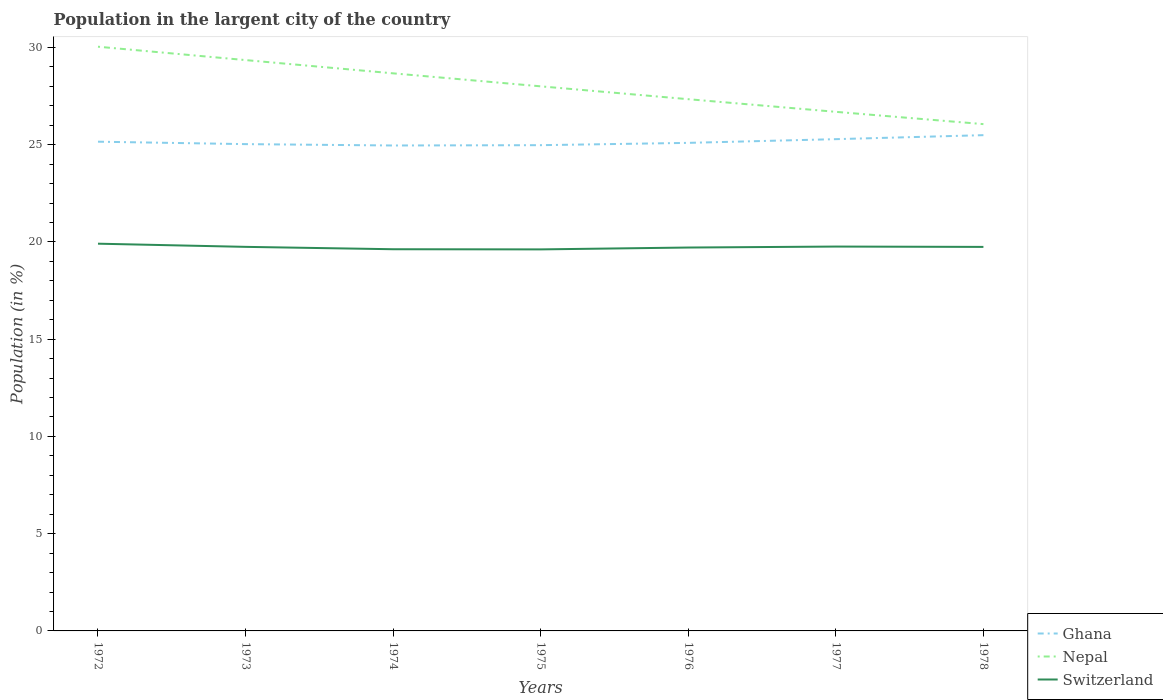Does the line corresponding to Ghana intersect with the line corresponding to Switzerland?
Offer a very short reply. No. Across all years, what is the maximum percentage of population in the largent city in Nepal?
Make the answer very short. 26.06. In which year was the percentage of population in the largent city in Nepal maximum?
Ensure brevity in your answer.  1978. What is the total percentage of population in the largent city in Ghana in the graph?
Ensure brevity in your answer.  -0.34. What is the difference between the highest and the second highest percentage of population in the largent city in Switzerland?
Ensure brevity in your answer.  0.29. What is the difference between the highest and the lowest percentage of population in the largent city in Ghana?
Give a very brief answer. 3. Are the values on the major ticks of Y-axis written in scientific E-notation?
Offer a very short reply. No. Does the graph contain grids?
Your answer should be compact. No. Where does the legend appear in the graph?
Your answer should be compact. Bottom right. How many legend labels are there?
Ensure brevity in your answer.  3. What is the title of the graph?
Offer a very short reply. Population in the largent city of the country. Does "Benin" appear as one of the legend labels in the graph?
Offer a terse response. No. What is the label or title of the X-axis?
Your response must be concise. Years. What is the label or title of the Y-axis?
Provide a succinct answer. Population (in %). What is the Population (in %) of Ghana in 1972?
Provide a succinct answer. 25.15. What is the Population (in %) of Nepal in 1972?
Make the answer very short. 30.04. What is the Population (in %) in Switzerland in 1972?
Ensure brevity in your answer.  19.91. What is the Population (in %) in Ghana in 1973?
Provide a short and direct response. 25.03. What is the Population (in %) of Nepal in 1973?
Provide a short and direct response. 29.35. What is the Population (in %) in Switzerland in 1973?
Offer a very short reply. 19.75. What is the Population (in %) of Ghana in 1974?
Ensure brevity in your answer.  24.96. What is the Population (in %) of Nepal in 1974?
Your answer should be very brief. 28.67. What is the Population (in %) in Switzerland in 1974?
Provide a short and direct response. 19.62. What is the Population (in %) in Ghana in 1975?
Give a very brief answer. 24.97. What is the Population (in %) of Nepal in 1975?
Provide a short and direct response. 28. What is the Population (in %) of Switzerland in 1975?
Offer a terse response. 19.62. What is the Population (in %) in Ghana in 1976?
Your answer should be compact. 25.09. What is the Population (in %) in Nepal in 1976?
Provide a succinct answer. 27.34. What is the Population (in %) in Switzerland in 1976?
Ensure brevity in your answer.  19.71. What is the Population (in %) in Ghana in 1977?
Offer a terse response. 25.28. What is the Population (in %) of Nepal in 1977?
Your answer should be very brief. 26.69. What is the Population (in %) of Switzerland in 1977?
Your response must be concise. 19.76. What is the Population (in %) of Ghana in 1978?
Your answer should be very brief. 25.49. What is the Population (in %) in Nepal in 1978?
Provide a short and direct response. 26.06. What is the Population (in %) in Switzerland in 1978?
Provide a short and direct response. 19.74. Across all years, what is the maximum Population (in %) of Ghana?
Your answer should be very brief. 25.49. Across all years, what is the maximum Population (in %) in Nepal?
Your answer should be very brief. 30.04. Across all years, what is the maximum Population (in %) in Switzerland?
Make the answer very short. 19.91. Across all years, what is the minimum Population (in %) in Ghana?
Provide a succinct answer. 24.96. Across all years, what is the minimum Population (in %) in Nepal?
Your answer should be very brief. 26.06. Across all years, what is the minimum Population (in %) in Switzerland?
Give a very brief answer. 19.62. What is the total Population (in %) of Ghana in the graph?
Your answer should be very brief. 175.98. What is the total Population (in %) in Nepal in the graph?
Your answer should be very brief. 196.13. What is the total Population (in %) of Switzerland in the graph?
Your response must be concise. 138.11. What is the difference between the Population (in %) of Ghana in 1972 and that in 1973?
Your answer should be very brief. 0.12. What is the difference between the Population (in %) of Nepal in 1972 and that in 1973?
Your response must be concise. 0.69. What is the difference between the Population (in %) in Switzerland in 1972 and that in 1973?
Ensure brevity in your answer.  0.16. What is the difference between the Population (in %) in Ghana in 1972 and that in 1974?
Your response must be concise. 0.2. What is the difference between the Population (in %) of Nepal in 1972 and that in 1974?
Your response must be concise. 1.37. What is the difference between the Population (in %) in Switzerland in 1972 and that in 1974?
Offer a terse response. 0.29. What is the difference between the Population (in %) in Ghana in 1972 and that in 1975?
Make the answer very short. 0.18. What is the difference between the Population (in %) of Nepal in 1972 and that in 1975?
Provide a succinct answer. 2.04. What is the difference between the Population (in %) of Switzerland in 1972 and that in 1975?
Give a very brief answer. 0.29. What is the difference between the Population (in %) of Ghana in 1972 and that in 1976?
Your answer should be very brief. 0.06. What is the difference between the Population (in %) in Nepal in 1972 and that in 1976?
Your response must be concise. 2.7. What is the difference between the Population (in %) of Switzerland in 1972 and that in 1976?
Keep it short and to the point. 0.2. What is the difference between the Population (in %) of Ghana in 1972 and that in 1977?
Provide a succinct answer. -0.13. What is the difference between the Population (in %) in Nepal in 1972 and that in 1977?
Ensure brevity in your answer.  3.35. What is the difference between the Population (in %) in Switzerland in 1972 and that in 1977?
Give a very brief answer. 0.15. What is the difference between the Population (in %) of Ghana in 1972 and that in 1978?
Offer a very short reply. -0.34. What is the difference between the Population (in %) in Nepal in 1972 and that in 1978?
Offer a terse response. 3.98. What is the difference between the Population (in %) of Switzerland in 1972 and that in 1978?
Provide a short and direct response. 0.17. What is the difference between the Population (in %) of Ghana in 1973 and that in 1974?
Your answer should be very brief. 0.07. What is the difference between the Population (in %) in Nepal in 1973 and that in 1974?
Offer a very short reply. 0.68. What is the difference between the Population (in %) of Switzerland in 1973 and that in 1974?
Offer a terse response. 0.12. What is the difference between the Population (in %) in Ghana in 1973 and that in 1975?
Provide a short and direct response. 0.05. What is the difference between the Population (in %) of Nepal in 1973 and that in 1975?
Offer a very short reply. 1.35. What is the difference between the Population (in %) in Switzerland in 1973 and that in 1975?
Give a very brief answer. 0.13. What is the difference between the Population (in %) in Ghana in 1973 and that in 1976?
Keep it short and to the point. -0.06. What is the difference between the Population (in %) in Nepal in 1973 and that in 1976?
Keep it short and to the point. 2.01. What is the difference between the Population (in %) of Switzerland in 1973 and that in 1976?
Give a very brief answer. 0.03. What is the difference between the Population (in %) in Ghana in 1973 and that in 1977?
Your answer should be very brief. -0.26. What is the difference between the Population (in %) of Nepal in 1973 and that in 1977?
Provide a succinct answer. 2.66. What is the difference between the Population (in %) of Switzerland in 1973 and that in 1977?
Offer a terse response. -0.02. What is the difference between the Population (in %) of Ghana in 1973 and that in 1978?
Give a very brief answer. -0.46. What is the difference between the Population (in %) of Nepal in 1973 and that in 1978?
Keep it short and to the point. 3.29. What is the difference between the Population (in %) of Switzerland in 1973 and that in 1978?
Your answer should be very brief. 0. What is the difference between the Population (in %) of Ghana in 1974 and that in 1975?
Keep it short and to the point. -0.02. What is the difference between the Population (in %) in Nepal in 1974 and that in 1975?
Provide a succinct answer. 0.67. What is the difference between the Population (in %) of Switzerland in 1974 and that in 1975?
Provide a short and direct response. 0.01. What is the difference between the Population (in %) in Ghana in 1974 and that in 1976?
Offer a very short reply. -0.14. What is the difference between the Population (in %) in Nepal in 1974 and that in 1976?
Ensure brevity in your answer.  1.33. What is the difference between the Population (in %) in Switzerland in 1974 and that in 1976?
Offer a very short reply. -0.09. What is the difference between the Population (in %) of Ghana in 1974 and that in 1977?
Keep it short and to the point. -0.33. What is the difference between the Population (in %) of Nepal in 1974 and that in 1977?
Your answer should be compact. 1.98. What is the difference between the Population (in %) of Switzerland in 1974 and that in 1977?
Offer a terse response. -0.14. What is the difference between the Population (in %) in Ghana in 1974 and that in 1978?
Make the answer very short. -0.53. What is the difference between the Population (in %) in Nepal in 1974 and that in 1978?
Your response must be concise. 2.61. What is the difference between the Population (in %) in Switzerland in 1974 and that in 1978?
Your answer should be very brief. -0.12. What is the difference between the Population (in %) of Ghana in 1975 and that in 1976?
Your answer should be compact. -0.12. What is the difference between the Population (in %) of Nepal in 1975 and that in 1976?
Your answer should be very brief. 0.66. What is the difference between the Population (in %) of Switzerland in 1975 and that in 1976?
Your answer should be compact. -0.1. What is the difference between the Population (in %) in Ghana in 1975 and that in 1977?
Ensure brevity in your answer.  -0.31. What is the difference between the Population (in %) of Nepal in 1975 and that in 1977?
Keep it short and to the point. 1.31. What is the difference between the Population (in %) in Switzerland in 1975 and that in 1977?
Your answer should be very brief. -0.15. What is the difference between the Population (in %) of Ghana in 1975 and that in 1978?
Offer a very short reply. -0.51. What is the difference between the Population (in %) of Nepal in 1975 and that in 1978?
Your answer should be very brief. 1.94. What is the difference between the Population (in %) of Switzerland in 1975 and that in 1978?
Your response must be concise. -0.13. What is the difference between the Population (in %) of Ghana in 1976 and that in 1977?
Make the answer very short. -0.19. What is the difference between the Population (in %) in Nepal in 1976 and that in 1977?
Provide a short and direct response. 0.65. What is the difference between the Population (in %) in Switzerland in 1976 and that in 1977?
Offer a terse response. -0.05. What is the difference between the Population (in %) in Ghana in 1976 and that in 1978?
Offer a terse response. -0.4. What is the difference between the Population (in %) in Nepal in 1976 and that in 1978?
Keep it short and to the point. 1.28. What is the difference between the Population (in %) of Switzerland in 1976 and that in 1978?
Your response must be concise. -0.03. What is the difference between the Population (in %) of Ghana in 1977 and that in 1978?
Your answer should be very brief. -0.21. What is the difference between the Population (in %) in Nepal in 1977 and that in 1978?
Ensure brevity in your answer.  0.63. What is the difference between the Population (in %) of Switzerland in 1977 and that in 1978?
Give a very brief answer. 0.02. What is the difference between the Population (in %) of Ghana in 1972 and the Population (in %) of Nepal in 1973?
Provide a short and direct response. -4.2. What is the difference between the Population (in %) of Ghana in 1972 and the Population (in %) of Switzerland in 1973?
Ensure brevity in your answer.  5.41. What is the difference between the Population (in %) of Nepal in 1972 and the Population (in %) of Switzerland in 1973?
Offer a terse response. 10.29. What is the difference between the Population (in %) in Ghana in 1972 and the Population (in %) in Nepal in 1974?
Offer a very short reply. -3.51. What is the difference between the Population (in %) of Ghana in 1972 and the Population (in %) of Switzerland in 1974?
Offer a terse response. 5.53. What is the difference between the Population (in %) of Nepal in 1972 and the Population (in %) of Switzerland in 1974?
Your answer should be compact. 10.41. What is the difference between the Population (in %) in Ghana in 1972 and the Population (in %) in Nepal in 1975?
Your answer should be very brief. -2.85. What is the difference between the Population (in %) in Ghana in 1972 and the Population (in %) in Switzerland in 1975?
Provide a succinct answer. 5.54. What is the difference between the Population (in %) of Nepal in 1972 and the Population (in %) of Switzerland in 1975?
Your answer should be very brief. 10.42. What is the difference between the Population (in %) in Ghana in 1972 and the Population (in %) in Nepal in 1976?
Give a very brief answer. -2.18. What is the difference between the Population (in %) in Ghana in 1972 and the Population (in %) in Switzerland in 1976?
Give a very brief answer. 5.44. What is the difference between the Population (in %) of Nepal in 1972 and the Population (in %) of Switzerland in 1976?
Your answer should be compact. 10.32. What is the difference between the Population (in %) of Ghana in 1972 and the Population (in %) of Nepal in 1977?
Keep it short and to the point. -1.53. What is the difference between the Population (in %) of Ghana in 1972 and the Population (in %) of Switzerland in 1977?
Make the answer very short. 5.39. What is the difference between the Population (in %) of Nepal in 1972 and the Population (in %) of Switzerland in 1977?
Ensure brevity in your answer.  10.27. What is the difference between the Population (in %) in Ghana in 1972 and the Population (in %) in Nepal in 1978?
Ensure brevity in your answer.  -0.9. What is the difference between the Population (in %) in Ghana in 1972 and the Population (in %) in Switzerland in 1978?
Give a very brief answer. 5.41. What is the difference between the Population (in %) of Nepal in 1972 and the Population (in %) of Switzerland in 1978?
Make the answer very short. 10.29. What is the difference between the Population (in %) in Ghana in 1973 and the Population (in %) in Nepal in 1974?
Offer a very short reply. -3.64. What is the difference between the Population (in %) of Ghana in 1973 and the Population (in %) of Switzerland in 1974?
Provide a succinct answer. 5.4. What is the difference between the Population (in %) of Nepal in 1973 and the Population (in %) of Switzerland in 1974?
Provide a succinct answer. 9.73. What is the difference between the Population (in %) in Ghana in 1973 and the Population (in %) in Nepal in 1975?
Your response must be concise. -2.97. What is the difference between the Population (in %) in Ghana in 1973 and the Population (in %) in Switzerland in 1975?
Give a very brief answer. 5.41. What is the difference between the Population (in %) of Nepal in 1973 and the Population (in %) of Switzerland in 1975?
Provide a succinct answer. 9.73. What is the difference between the Population (in %) in Ghana in 1973 and the Population (in %) in Nepal in 1976?
Provide a succinct answer. -2.31. What is the difference between the Population (in %) of Ghana in 1973 and the Population (in %) of Switzerland in 1976?
Provide a succinct answer. 5.32. What is the difference between the Population (in %) in Nepal in 1973 and the Population (in %) in Switzerland in 1976?
Your answer should be very brief. 9.64. What is the difference between the Population (in %) of Ghana in 1973 and the Population (in %) of Nepal in 1977?
Make the answer very short. -1.66. What is the difference between the Population (in %) in Ghana in 1973 and the Population (in %) in Switzerland in 1977?
Offer a terse response. 5.27. What is the difference between the Population (in %) in Nepal in 1973 and the Population (in %) in Switzerland in 1977?
Offer a terse response. 9.59. What is the difference between the Population (in %) of Ghana in 1973 and the Population (in %) of Nepal in 1978?
Your response must be concise. -1.03. What is the difference between the Population (in %) in Ghana in 1973 and the Population (in %) in Switzerland in 1978?
Keep it short and to the point. 5.28. What is the difference between the Population (in %) in Nepal in 1973 and the Population (in %) in Switzerland in 1978?
Offer a terse response. 9.61. What is the difference between the Population (in %) of Ghana in 1974 and the Population (in %) of Nepal in 1975?
Your answer should be very brief. -3.04. What is the difference between the Population (in %) of Ghana in 1974 and the Population (in %) of Switzerland in 1975?
Provide a succinct answer. 5.34. What is the difference between the Population (in %) of Nepal in 1974 and the Population (in %) of Switzerland in 1975?
Keep it short and to the point. 9.05. What is the difference between the Population (in %) of Ghana in 1974 and the Population (in %) of Nepal in 1976?
Offer a very short reply. -2.38. What is the difference between the Population (in %) in Ghana in 1974 and the Population (in %) in Switzerland in 1976?
Provide a short and direct response. 5.25. What is the difference between the Population (in %) of Nepal in 1974 and the Population (in %) of Switzerland in 1976?
Offer a terse response. 8.96. What is the difference between the Population (in %) of Ghana in 1974 and the Population (in %) of Nepal in 1977?
Offer a terse response. -1.73. What is the difference between the Population (in %) of Ghana in 1974 and the Population (in %) of Switzerland in 1977?
Provide a succinct answer. 5.2. What is the difference between the Population (in %) of Nepal in 1974 and the Population (in %) of Switzerland in 1977?
Your answer should be very brief. 8.91. What is the difference between the Population (in %) in Ghana in 1974 and the Population (in %) in Nepal in 1978?
Offer a very short reply. -1.1. What is the difference between the Population (in %) in Ghana in 1974 and the Population (in %) in Switzerland in 1978?
Give a very brief answer. 5.21. What is the difference between the Population (in %) of Nepal in 1974 and the Population (in %) of Switzerland in 1978?
Give a very brief answer. 8.92. What is the difference between the Population (in %) in Ghana in 1975 and the Population (in %) in Nepal in 1976?
Make the answer very short. -2.36. What is the difference between the Population (in %) of Ghana in 1975 and the Population (in %) of Switzerland in 1976?
Keep it short and to the point. 5.26. What is the difference between the Population (in %) in Nepal in 1975 and the Population (in %) in Switzerland in 1976?
Keep it short and to the point. 8.29. What is the difference between the Population (in %) in Ghana in 1975 and the Population (in %) in Nepal in 1977?
Your answer should be compact. -1.71. What is the difference between the Population (in %) in Ghana in 1975 and the Population (in %) in Switzerland in 1977?
Give a very brief answer. 5.21. What is the difference between the Population (in %) in Nepal in 1975 and the Population (in %) in Switzerland in 1977?
Offer a terse response. 8.24. What is the difference between the Population (in %) in Ghana in 1975 and the Population (in %) in Nepal in 1978?
Offer a terse response. -1.08. What is the difference between the Population (in %) in Ghana in 1975 and the Population (in %) in Switzerland in 1978?
Offer a terse response. 5.23. What is the difference between the Population (in %) in Nepal in 1975 and the Population (in %) in Switzerland in 1978?
Give a very brief answer. 8.26. What is the difference between the Population (in %) in Ghana in 1976 and the Population (in %) in Nepal in 1977?
Give a very brief answer. -1.6. What is the difference between the Population (in %) in Ghana in 1976 and the Population (in %) in Switzerland in 1977?
Ensure brevity in your answer.  5.33. What is the difference between the Population (in %) in Nepal in 1976 and the Population (in %) in Switzerland in 1977?
Provide a succinct answer. 7.58. What is the difference between the Population (in %) in Ghana in 1976 and the Population (in %) in Nepal in 1978?
Provide a short and direct response. -0.96. What is the difference between the Population (in %) of Ghana in 1976 and the Population (in %) of Switzerland in 1978?
Ensure brevity in your answer.  5.35. What is the difference between the Population (in %) of Nepal in 1976 and the Population (in %) of Switzerland in 1978?
Make the answer very short. 7.59. What is the difference between the Population (in %) in Ghana in 1977 and the Population (in %) in Nepal in 1978?
Offer a very short reply. -0.77. What is the difference between the Population (in %) in Ghana in 1977 and the Population (in %) in Switzerland in 1978?
Offer a very short reply. 5.54. What is the difference between the Population (in %) of Nepal in 1977 and the Population (in %) of Switzerland in 1978?
Make the answer very short. 6.94. What is the average Population (in %) in Ghana per year?
Provide a short and direct response. 25.14. What is the average Population (in %) of Nepal per year?
Provide a short and direct response. 28.02. What is the average Population (in %) in Switzerland per year?
Offer a very short reply. 19.73. In the year 1972, what is the difference between the Population (in %) of Ghana and Population (in %) of Nepal?
Offer a terse response. -4.88. In the year 1972, what is the difference between the Population (in %) of Ghana and Population (in %) of Switzerland?
Ensure brevity in your answer.  5.24. In the year 1972, what is the difference between the Population (in %) of Nepal and Population (in %) of Switzerland?
Offer a very short reply. 10.13. In the year 1973, what is the difference between the Population (in %) of Ghana and Population (in %) of Nepal?
Ensure brevity in your answer.  -4.32. In the year 1973, what is the difference between the Population (in %) of Ghana and Population (in %) of Switzerland?
Your response must be concise. 5.28. In the year 1973, what is the difference between the Population (in %) in Nepal and Population (in %) in Switzerland?
Your response must be concise. 9.6. In the year 1974, what is the difference between the Population (in %) of Ghana and Population (in %) of Nepal?
Offer a very short reply. -3.71. In the year 1974, what is the difference between the Population (in %) in Ghana and Population (in %) in Switzerland?
Keep it short and to the point. 5.33. In the year 1974, what is the difference between the Population (in %) of Nepal and Population (in %) of Switzerland?
Your response must be concise. 9.04. In the year 1975, what is the difference between the Population (in %) in Ghana and Population (in %) in Nepal?
Your answer should be very brief. -3.02. In the year 1975, what is the difference between the Population (in %) of Ghana and Population (in %) of Switzerland?
Provide a short and direct response. 5.36. In the year 1975, what is the difference between the Population (in %) in Nepal and Population (in %) in Switzerland?
Offer a terse response. 8.38. In the year 1976, what is the difference between the Population (in %) of Ghana and Population (in %) of Nepal?
Your answer should be very brief. -2.25. In the year 1976, what is the difference between the Population (in %) of Ghana and Population (in %) of Switzerland?
Make the answer very short. 5.38. In the year 1976, what is the difference between the Population (in %) of Nepal and Population (in %) of Switzerland?
Ensure brevity in your answer.  7.63. In the year 1977, what is the difference between the Population (in %) in Ghana and Population (in %) in Nepal?
Your answer should be compact. -1.4. In the year 1977, what is the difference between the Population (in %) of Ghana and Population (in %) of Switzerland?
Make the answer very short. 5.52. In the year 1977, what is the difference between the Population (in %) of Nepal and Population (in %) of Switzerland?
Give a very brief answer. 6.93. In the year 1978, what is the difference between the Population (in %) of Ghana and Population (in %) of Nepal?
Keep it short and to the point. -0.57. In the year 1978, what is the difference between the Population (in %) in Ghana and Population (in %) in Switzerland?
Make the answer very short. 5.75. In the year 1978, what is the difference between the Population (in %) in Nepal and Population (in %) in Switzerland?
Provide a succinct answer. 6.31. What is the ratio of the Population (in %) of Nepal in 1972 to that in 1973?
Ensure brevity in your answer.  1.02. What is the ratio of the Population (in %) in Switzerland in 1972 to that in 1973?
Offer a terse response. 1.01. What is the ratio of the Population (in %) in Ghana in 1972 to that in 1974?
Give a very brief answer. 1.01. What is the ratio of the Population (in %) in Nepal in 1972 to that in 1974?
Keep it short and to the point. 1.05. What is the ratio of the Population (in %) in Switzerland in 1972 to that in 1974?
Offer a very short reply. 1.01. What is the ratio of the Population (in %) of Ghana in 1972 to that in 1975?
Make the answer very short. 1.01. What is the ratio of the Population (in %) in Nepal in 1972 to that in 1975?
Give a very brief answer. 1.07. What is the ratio of the Population (in %) of Switzerland in 1972 to that in 1975?
Your answer should be very brief. 1.01. What is the ratio of the Population (in %) in Ghana in 1972 to that in 1976?
Offer a very short reply. 1. What is the ratio of the Population (in %) in Nepal in 1972 to that in 1976?
Provide a succinct answer. 1.1. What is the ratio of the Population (in %) of Ghana in 1972 to that in 1977?
Provide a succinct answer. 0.99. What is the ratio of the Population (in %) in Nepal in 1972 to that in 1977?
Provide a succinct answer. 1.13. What is the ratio of the Population (in %) in Switzerland in 1972 to that in 1977?
Ensure brevity in your answer.  1.01. What is the ratio of the Population (in %) of Nepal in 1972 to that in 1978?
Keep it short and to the point. 1.15. What is the ratio of the Population (in %) in Switzerland in 1972 to that in 1978?
Ensure brevity in your answer.  1.01. What is the ratio of the Population (in %) of Nepal in 1973 to that in 1974?
Offer a terse response. 1.02. What is the ratio of the Population (in %) in Nepal in 1973 to that in 1975?
Your answer should be very brief. 1.05. What is the ratio of the Population (in %) in Nepal in 1973 to that in 1976?
Keep it short and to the point. 1.07. What is the ratio of the Population (in %) of Ghana in 1973 to that in 1977?
Provide a succinct answer. 0.99. What is the ratio of the Population (in %) of Nepal in 1973 to that in 1977?
Your response must be concise. 1.1. What is the ratio of the Population (in %) of Ghana in 1973 to that in 1978?
Your answer should be compact. 0.98. What is the ratio of the Population (in %) in Nepal in 1973 to that in 1978?
Your answer should be compact. 1.13. What is the ratio of the Population (in %) of Switzerland in 1973 to that in 1978?
Give a very brief answer. 1. What is the ratio of the Population (in %) of Ghana in 1974 to that in 1975?
Your answer should be very brief. 1. What is the ratio of the Population (in %) in Nepal in 1974 to that in 1975?
Your answer should be compact. 1.02. What is the ratio of the Population (in %) of Switzerland in 1974 to that in 1975?
Keep it short and to the point. 1. What is the ratio of the Population (in %) of Ghana in 1974 to that in 1976?
Make the answer very short. 0.99. What is the ratio of the Population (in %) of Nepal in 1974 to that in 1976?
Make the answer very short. 1.05. What is the ratio of the Population (in %) of Switzerland in 1974 to that in 1976?
Offer a very short reply. 1. What is the ratio of the Population (in %) in Ghana in 1974 to that in 1977?
Your response must be concise. 0.99. What is the ratio of the Population (in %) in Nepal in 1974 to that in 1977?
Offer a very short reply. 1.07. What is the ratio of the Population (in %) in Ghana in 1974 to that in 1978?
Your response must be concise. 0.98. What is the ratio of the Population (in %) in Nepal in 1974 to that in 1978?
Ensure brevity in your answer.  1.1. What is the ratio of the Population (in %) of Switzerland in 1974 to that in 1978?
Keep it short and to the point. 0.99. What is the ratio of the Population (in %) of Nepal in 1975 to that in 1976?
Give a very brief answer. 1.02. What is the ratio of the Population (in %) in Nepal in 1975 to that in 1977?
Your answer should be very brief. 1.05. What is the ratio of the Population (in %) of Switzerland in 1975 to that in 1977?
Offer a terse response. 0.99. What is the ratio of the Population (in %) in Ghana in 1975 to that in 1978?
Keep it short and to the point. 0.98. What is the ratio of the Population (in %) of Nepal in 1975 to that in 1978?
Give a very brief answer. 1.07. What is the ratio of the Population (in %) of Switzerland in 1975 to that in 1978?
Offer a very short reply. 0.99. What is the ratio of the Population (in %) of Nepal in 1976 to that in 1977?
Provide a short and direct response. 1.02. What is the ratio of the Population (in %) in Ghana in 1976 to that in 1978?
Give a very brief answer. 0.98. What is the ratio of the Population (in %) in Nepal in 1976 to that in 1978?
Provide a short and direct response. 1.05. What is the ratio of the Population (in %) in Switzerland in 1976 to that in 1978?
Provide a succinct answer. 1. What is the ratio of the Population (in %) in Ghana in 1977 to that in 1978?
Provide a succinct answer. 0.99. What is the ratio of the Population (in %) of Nepal in 1977 to that in 1978?
Your response must be concise. 1.02. What is the ratio of the Population (in %) in Switzerland in 1977 to that in 1978?
Your answer should be very brief. 1. What is the difference between the highest and the second highest Population (in %) of Ghana?
Provide a succinct answer. 0.21. What is the difference between the highest and the second highest Population (in %) in Nepal?
Make the answer very short. 0.69. What is the difference between the highest and the second highest Population (in %) in Switzerland?
Provide a short and direct response. 0.15. What is the difference between the highest and the lowest Population (in %) in Ghana?
Offer a very short reply. 0.53. What is the difference between the highest and the lowest Population (in %) in Nepal?
Provide a succinct answer. 3.98. What is the difference between the highest and the lowest Population (in %) in Switzerland?
Make the answer very short. 0.29. 